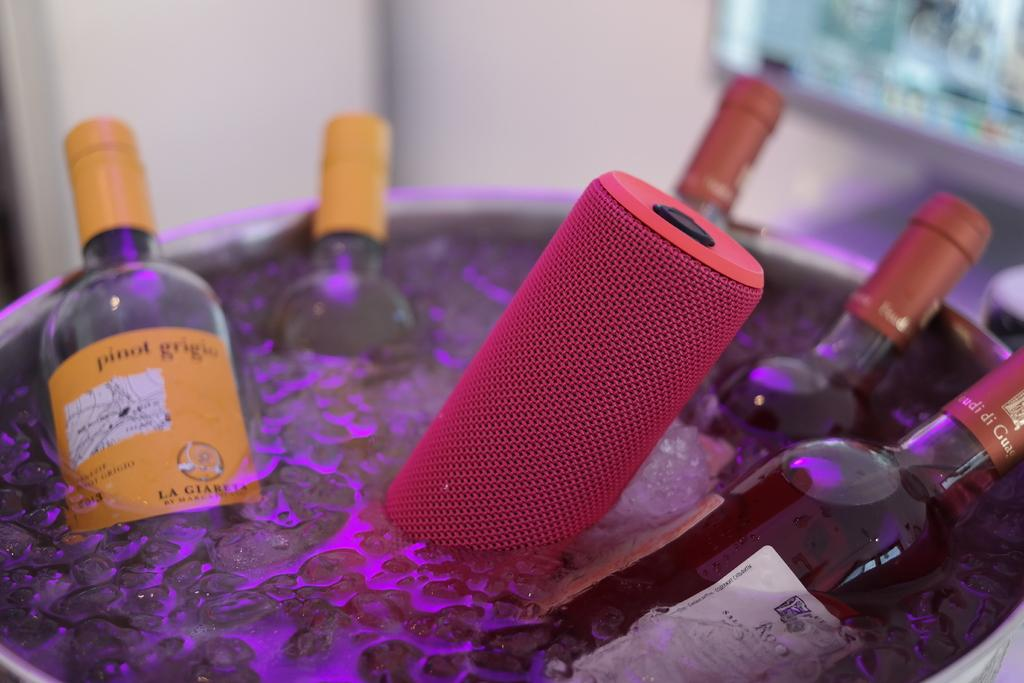How many bottles are visible in the image? There are five bottles in the image. What is the condition of the bottles in the image? The bottles are placed in water. How full is the water in the image? The water is full. What can be seen in the background of the image? There is a white color wall in the background of the image. What time of day is it in the image, and is there any dirt visible? The time of day is not mentioned in the image, and there is no dirt visible. 